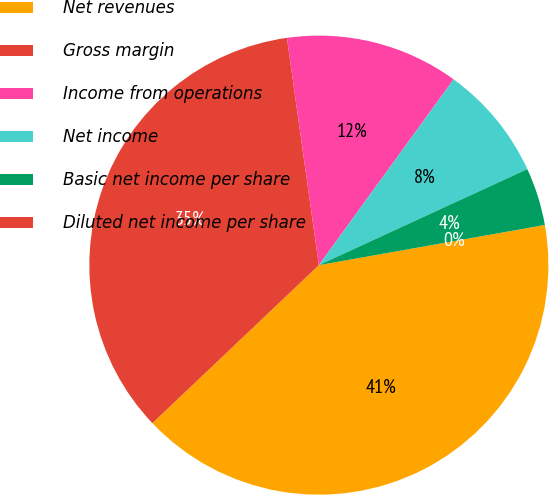Convert chart to OTSL. <chart><loc_0><loc_0><loc_500><loc_500><pie_chart><fcel>Net revenues<fcel>Gross margin<fcel>Income from operations<fcel>Net income<fcel>Basic net income per share<fcel>Diluted net income per share<nl><fcel>40.71%<fcel>34.86%<fcel>12.21%<fcel>8.14%<fcel>4.07%<fcel>0.0%<nl></chart> 